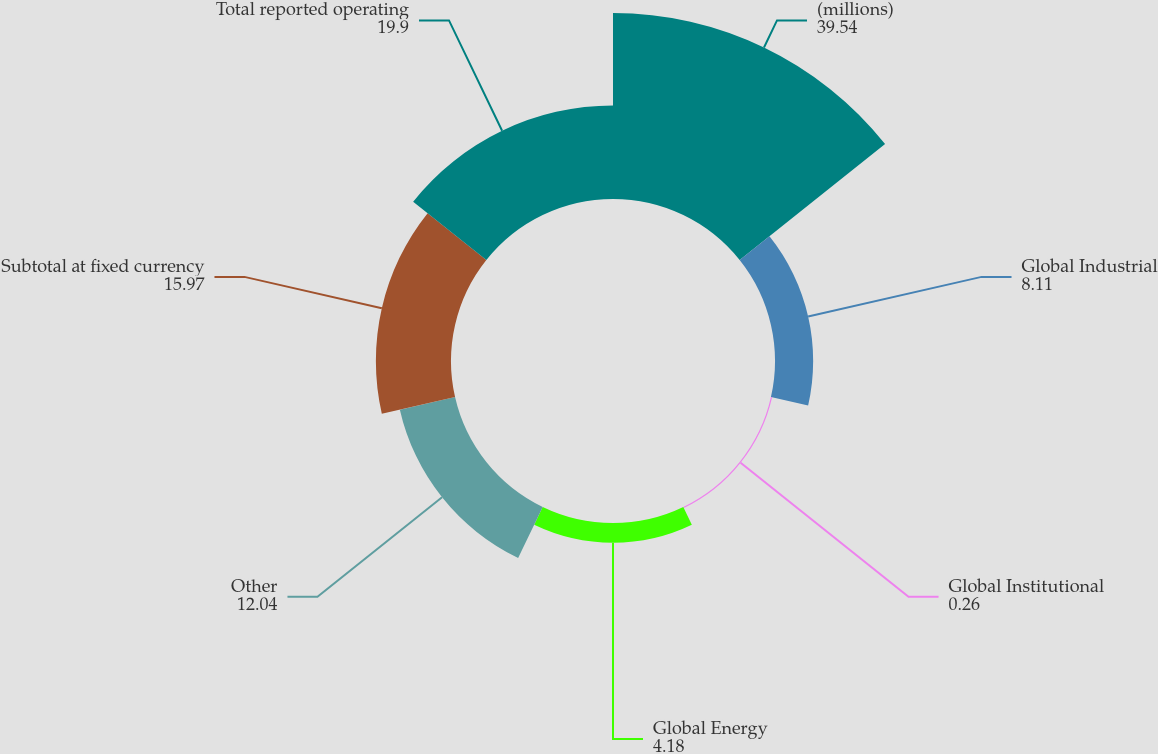Convert chart to OTSL. <chart><loc_0><loc_0><loc_500><loc_500><pie_chart><fcel>(millions)<fcel>Global Industrial<fcel>Global Institutional<fcel>Global Energy<fcel>Other<fcel>Subtotal at fixed currency<fcel>Total reported operating<nl><fcel>39.54%<fcel>8.11%<fcel>0.26%<fcel>4.18%<fcel>12.04%<fcel>15.97%<fcel>19.9%<nl></chart> 